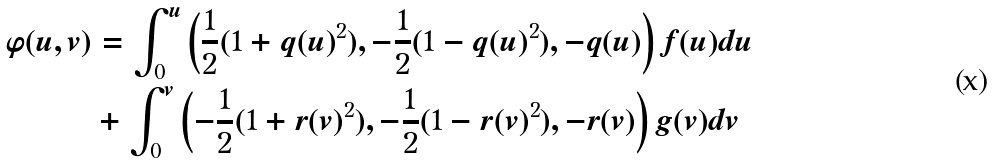<formula> <loc_0><loc_0><loc_500><loc_500>\varphi ( u , v ) & = \int _ { 0 } ^ { u } \left ( \frac { 1 } { 2 } ( 1 + q ( u ) ^ { 2 } ) , - \frac { 1 } { 2 } ( 1 - q ( u ) ^ { 2 } ) , - q ( u ) \right ) f ( u ) d u \\ & + \int _ { 0 } ^ { v } \left ( - \frac { 1 } { 2 } ( 1 + r ( v ) ^ { 2 } ) , - \frac { 1 } { 2 } ( 1 - r ( v ) ^ { 2 } ) , - r ( v ) \right ) g ( v ) d v</formula> 